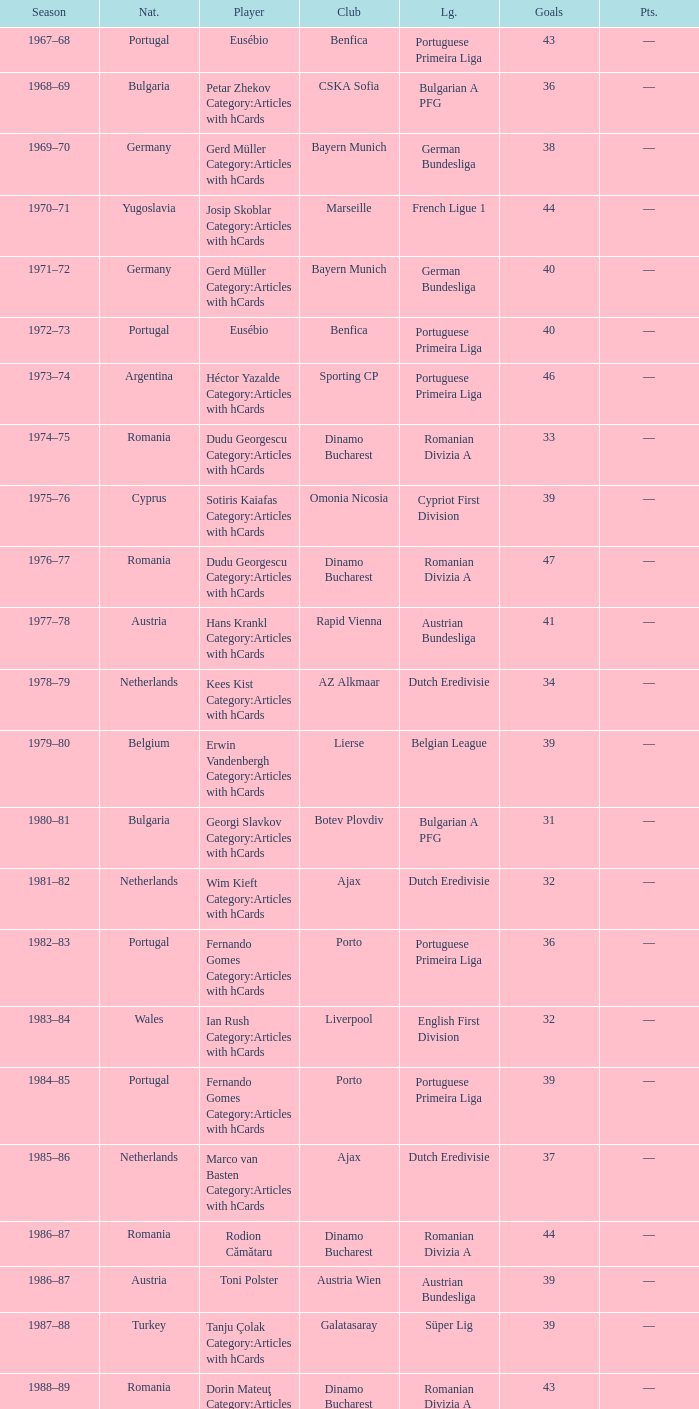Which league's nationality was Italy when there were 62 points? Italian Serie A. Would you be able to parse every entry in this table? {'header': ['Season', 'Nat.', 'Player', 'Club', 'Lg.', 'Goals', 'Pts.'], 'rows': [['1967–68', 'Portugal', 'Eusébio', 'Benfica', 'Portuguese Primeira Liga', '43', '—'], ['1968–69', 'Bulgaria', 'Petar Zhekov Category:Articles with hCards', 'CSKA Sofia', 'Bulgarian A PFG', '36', '—'], ['1969–70', 'Germany', 'Gerd Müller Category:Articles with hCards', 'Bayern Munich', 'German Bundesliga', '38', '—'], ['1970–71', 'Yugoslavia', 'Josip Skoblar Category:Articles with hCards', 'Marseille', 'French Ligue 1', '44', '—'], ['1971–72', 'Germany', 'Gerd Müller Category:Articles with hCards', 'Bayern Munich', 'German Bundesliga', '40', '—'], ['1972–73', 'Portugal', 'Eusébio', 'Benfica', 'Portuguese Primeira Liga', '40', '—'], ['1973–74', 'Argentina', 'Héctor Yazalde Category:Articles with hCards', 'Sporting CP', 'Portuguese Primeira Liga', '46', '—'], ['1974–75', 'Romania', 'Dudu Georgescu Category:Articles with hCards', 'Dinamo Bucharest', 'Romanian Divizia A', '33', '—'], ['1975–76', 'Cyprus', 'Sotiris Kaiafas Category:Articles with hCards', 'Omonia Nicosia', 'Cypriot First Division', '39', '—'], ['1976–77', 'Romania', 'Dudu Georgescu Category:Articles with hCards', 'Dinamo Bucharest', 'Romanian Divizia A', '47', '—'], ['1977–78', 'Austria', 'Hans Krankl Category:Articles with hCards', 'Rapid Vienna', 'Austrian Bundesliga', '41', '—'], ['1978–79', 'Netherlands', 'Kees Kist Category:Articles with hCards', 'AZ Alkmaar', 'Dutch Eredivisie', '34', '—'], ['1979–80', 'Belgium', 'Erwin Vandenbergh Category:Articles with hCards', 'Lierse', 'Belgian League', '39', '—'], ['1980–81', 'Bulgaria', 'Georgi Slavkov Category:Articles with hCards', 'Botev Plovdiv', 'Bulgarian A PFG', '31', '—'], ['1981–82', 'Netherlands', 'Wim Kieft Category:Articles with hCards', 'Ajax', 'Dutch Eredivisie', '32', '—'], ['1982–83', 'Portugal', 'Fernando Gomes Category:Articles with hCards', 'Porto', 'Portuguese Primeira Liga', '36', '—'], ['1983–84', 'Wales', 'Ian Rush Category:Articles with hCards', 'Liverpool', 'English First Division', '32', '—'], ['1984–85', 'Portugal', 'Fernando Gomes Category:Articles with hCards', 'Porto', 'Portuguese Primeira Liga', '39', '—'], ['1985–86', 'Netherlands', 'Marco van Basten Category:Articles with hCards', 'Ajax', 'Dutch Eredivisie', '37', '—'], ['1986–87', 'Romania', 'Rodion Cămătaru', 'Dinamo Bucharest', 'Romanian Divizia A', '44', '—'], ['1986–87', 'Austria', 'Toni Polster', 'Austria Wien', 'Austrian Bundesliga', '39', '—'], ['1987–88', 'Turkey', 'Tanju Çolak Category:Articles with hCards', 'Galatasaray', 'Süper Lig', '39', '—'], ['1988–89', 'Romania', 'Dorin Mateuţ Category:Articles with hCards', 'Dinamo Bucharest', 'Romanian Divizia A', '43', '—'], ['1989–90', 'Mexico', 'Hugo Sánchez Category:Articles with hCards', 'Real Madrid', 'Spanish La Liga', '38', '—'], ['1989–90', 'Bulgaria', 'Hristo Stoichkov Category:Articles with hCards', 'CSKA Sofia', 'Bulgarian A PFG', '38', '—'], ['1990–91', 'Yugoslavia', 'Darko Pančev Category:Articles with hCards', 'Red Star', 'Yugoslav First League', '34', '—'], ['1991–92', 'Scotland', 'Ally McCoist Category:Articles with hCards', 'Rangers', 'Scottish Premier Division', '34', '—'], ['1992–93', 'Scotland', 'Ally McCoist Category:Articles with hCards', 'Rangers', 'Scottish Premier Division', '34', '—'], ['1993–94', 'Wales', 'David Taylor Category:Articles with hCards', 'Porthmadog', 'League of Wales', '43', '—'], ['1994–95', 'Armenia', 'Arsen Avetisyan Category:Articles with hCards', 'Homenetmen', 'Armenian Premier League', '39', '—'], ['1995–96', 'Georgia', 'Zviad Endeladze Category:Articles with hCards', 'Margveti', 'Georgian Umaglesi Liga', '40', '—'], ['1996–97', 'Brazil', 'Ronaldo', 'Barcelona', 'Spanish La Liga', '34', '68'], ['1997–98', 'Greece', 'Nikos Machlas Category:Articles with hCards', 'Vitesse', 'Dutch Eredivisie', '34', '68'], ['1998–99', 'Brazil', 'Mário Jardel Category:Articles with hCards', 'Porto', 'Portuguese Primeira Liga', '36', '72'], ['1999–2000', 'England', 'Kevin Phillips Category:Articles with hCards', 'Sunderland', 'English Premier League', '30', '60'], ['2000–01', 'Sweden', 'Henrik Larsson Category:Articles with hCards', 'Celtic', 'Scottish Premier League', '35', '52.5'], ['2001–02', 'Brazil', 'Mário Jardel Category:Articles with hCards', 'Sporting CP', 'Portuguese Primeira Liga', '42', '84'], ['2002–03', 'Netherlands', 'Roy Makaay Category:Articles with hCards', 'Deportivo La Coruña', 'Spanish La Liga', '29', '58'], ['2003–04', 'France', 'Thierry Henry Category:Articles with hCards', 'Arsenal', 'English Premier League', '30', '60'], ['2004–05', 'France', 'Thierry Henry Category:Articles with hCards', 'Arsenal', 'English Premier League', '25', '50'], ['2004–05', 'Uruguay', 'Diego Forlán Category:Articles with hCards', 'Villarreal', 'Spanish La Liga', '25', '50'], ['2005–06', 'Italy', 'Luca Toni Category:Articles with hCards', 'Fiorentina', 'Italian Serie A', '31', '62'], ['2006–07', 'Italy', 'Francesco Totti Category:Articles with hCards', 'Roma', 'Italian Serie A', '26', '52'], ['2007–08', 'Portugal', 'Cristiano Ronaldo Category:Articles with hCards', 'Manchester United', 'English Premier League', '31', '62'], ['2008–09', 'Uruguay', 'Diego Forlán Category:Articles with hCards', 'Atlético Madrid', 'Spanish La Liga', '32', '64'], ['2009–10', 'Argentina', 'Lionel Messi Category:Articles with hCards', 'Barcelona', 'Spanish La Liga', '34', '68'], ['2010–11', 'Portugal', 'Cristiano Ronaldo Category:Articles with hCards', 'Real Madrid', 'Spanish La Liga', '40', '80'], ['2011–12', 'Argentina', 'Lionel Messi Category:Articles with hCards', 'Barcelona', 'Spanish La Liga', '50', '100'], ['2012–13', 'Argentina', 'Lionel Messi Category:Articles with hCards', 'Barcelona', 'Spanish La Liga', '46', '92']]} 